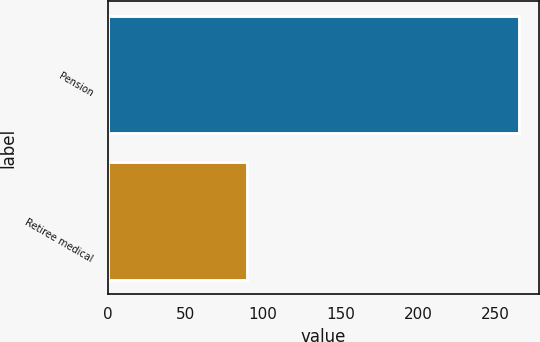Convert chart to OTSL. <chart><loc_0><loc_0><loc_500><loc_500><bar_chart><fcel>Pension<fcel>Retiree medical<nl><fcel>265<fcel>90<nl></chart> 